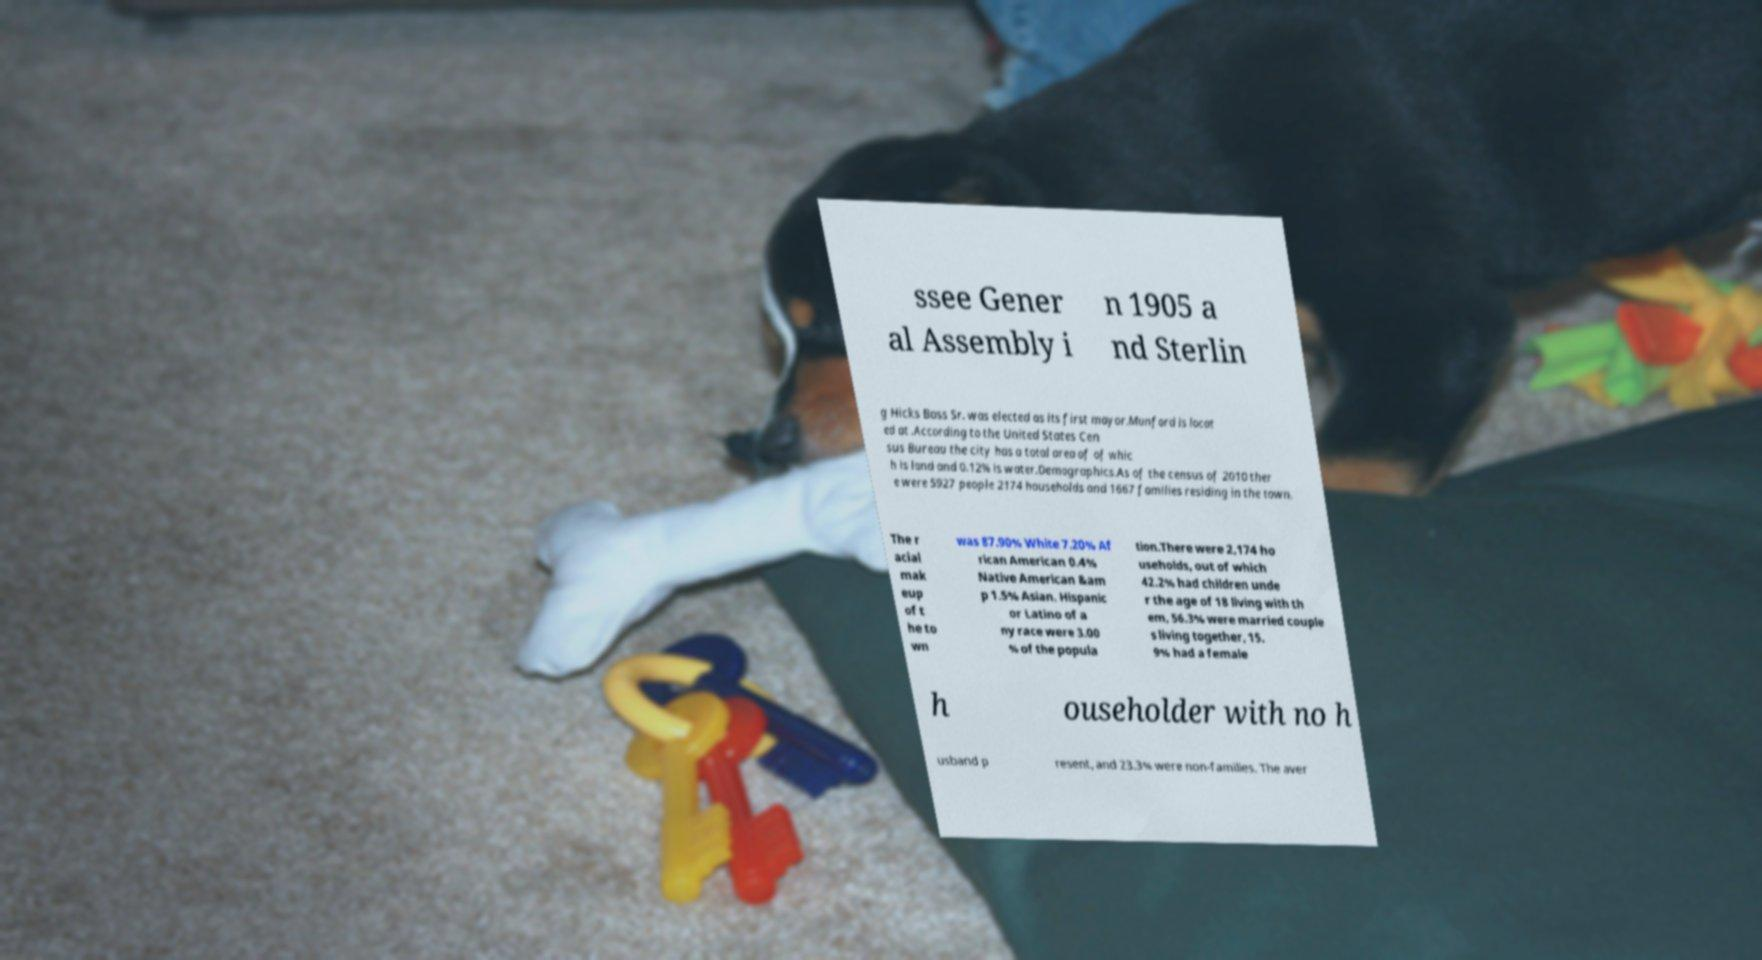Please identify and transcribe the text found in this image. ssee Gener al Assembly i n 1905 a nd Sterlin g Hicks Bass Sr. was elected as its first mayor.Munford is locat ed at .According to the United States Cen sus Bureau the city has a total area of of whic h is land and 0.12% is water.Demographics.As of the census of 2010 ther e were 5927 people 2174 households and 1667 families residing in the town. The r acial mak eup of t he to wn was 87.90% White 7.20% Af rican American 0.4% Native American &am p 1.5% Asian. Hispanic or Latino of a ny race were 3.00 % of the popula tion.There were 2,174 ho useholds, out of which 42.2% had children unde r the age of 18 living with th em, 56.3% were married couple s living together, 15. 9% had a female h ouseholder with no h usband p resent, and 23.3% were non-families. The aver 